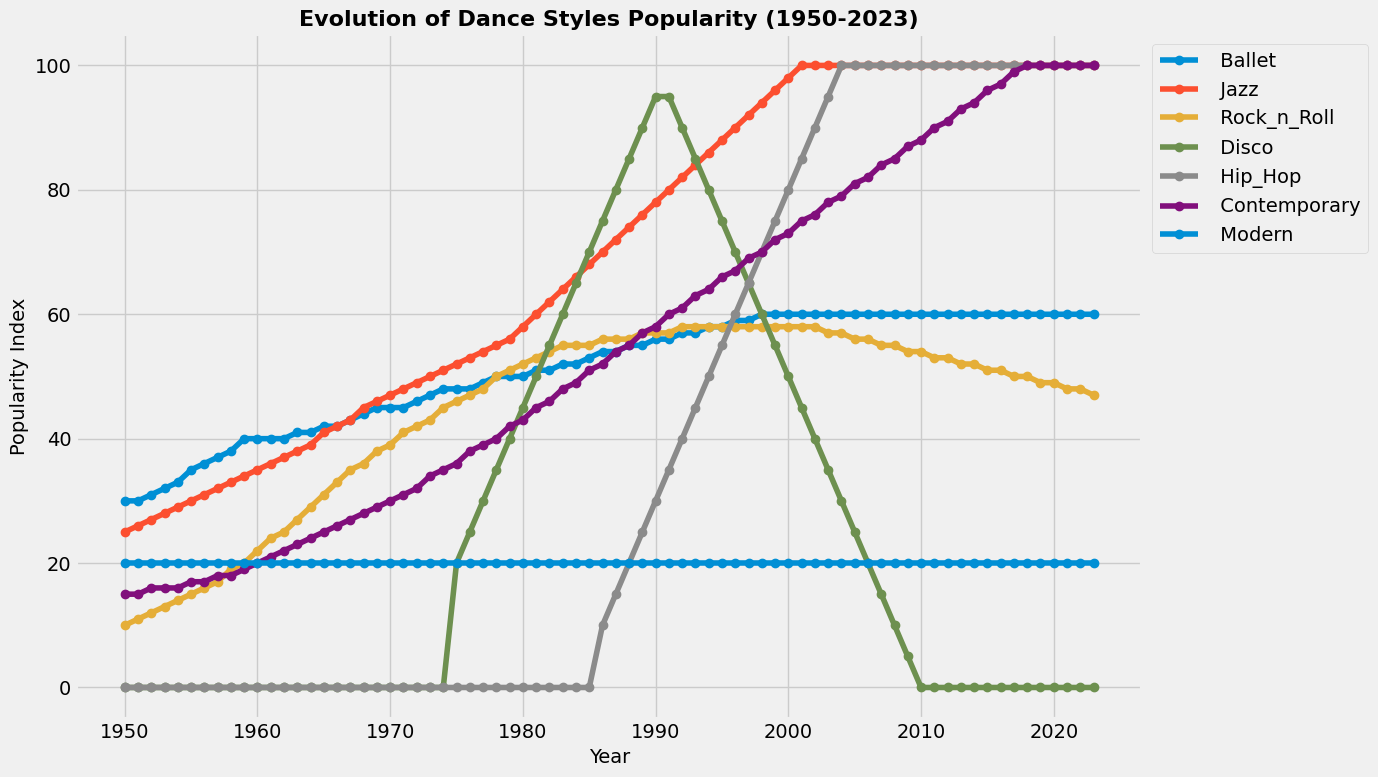How did the popularity of Disco dance style change between 1975 and 2010? The popularity index for Disco in 1975 was 20, and in 2010 it was 0. The change in popularity is 0 - 20 = -20, indicating a decrease.
Answer: Decreased by 20 Which dance style had the highest popularity in 2023? By examining the values for all dance styles in 2023, Hip_Hop had the highest popularity index with a value of 100.
Answer: Hip_Hop Between 1960 and 1990, which dance style had the most significant increase in popularity? Ballet had a popularity index of 40 in 1960 and increased to 56 by 1990, with an increase of 16. Jazz increased from 35 to 78 (43), Rock_n_Roll from 22 to 57 (35), Disco from 0 to 95 (95), and Hip_Hop from 0 to 30 (30). The most significant increase is in Disco with 95.
Answer: Disco From which year did Hip_Hop consistently maintain its highest popularity? By reviewing the data, Hip_Hop started to have its highest popularity from the year 2004 onwards, consistently maintaining a popularity index of 100.
Answer: 2004 What's the difference between the popularity of Rock_n_Roll and Contemporary in 1985? In 1985, the popularity of Rock_n_Roll was 55 and Contemporary was 51. The difference is 55 - 51 = 4.
Answer: 4 Which dance styles had a popularity index of 100 in 2012? Reviewing the data for 2012, Jazz, Hip_Hop, and Contemporary all had a popularity index of 100.
Answer: Jazz, Hip_Hop, Contemporary In what year did Jazz surpass Ballet in popularity? In 1967, Jazz had a popularity of 43, while Ballet had a popularity of 43 as well. The following year, in 1968, Jazz (45) surpassed Ballet (44).
Answer: 1968 What was the highest popularity index achieved by Disco, and in what year did it reach this peak? The highest popularity index for Disco was 95, which it reached in 1990.
Answer: 1990 In which decade did Contemporary dance style experience the most growth? Looking at the data, Contemporary grew from 51 in 1985 to 82 in 2006. The growth in this period (1985-2006) shows an increase of 31 over 20 years. The decade with the highest growth was the 1990s, as it grew from 66 in 1995 to 76 in 2002 (an increase of 10 in 7 years).
Answer: 1990s 